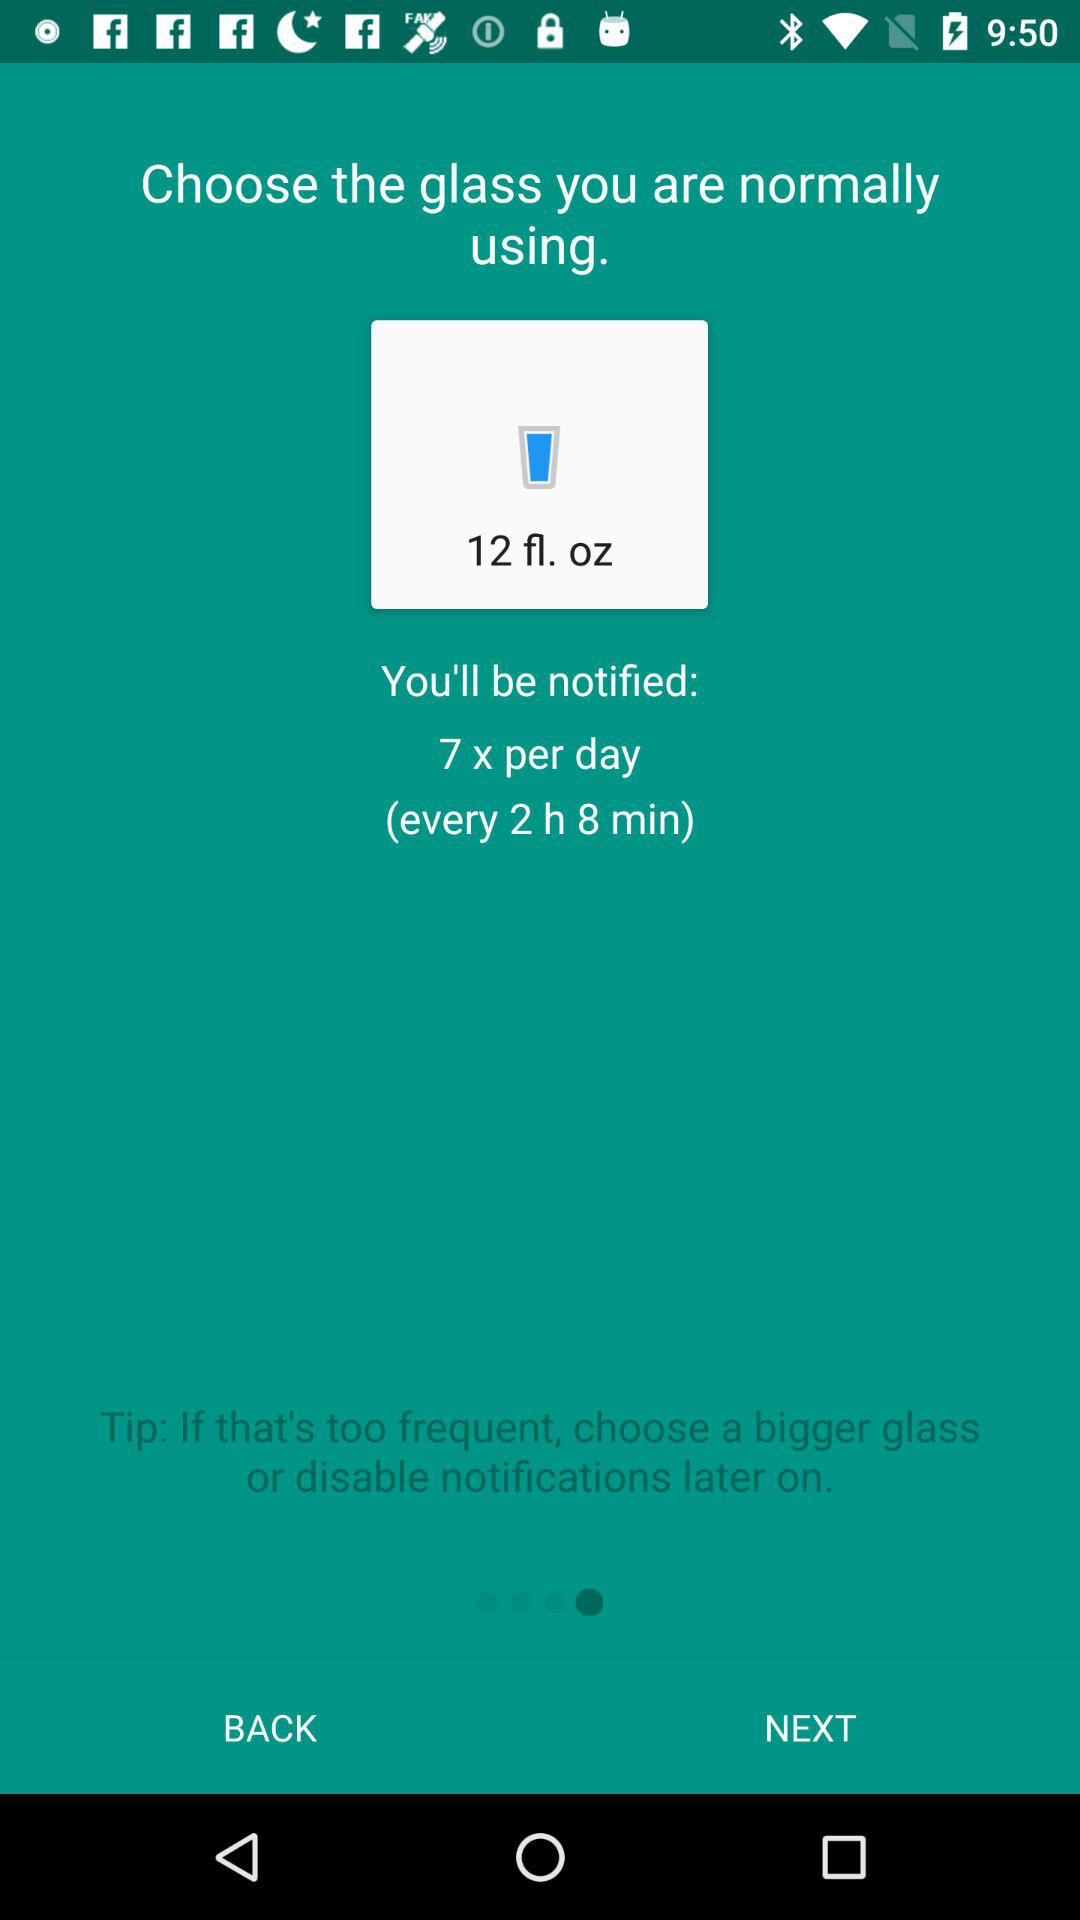What is the tip? The tip is "If that's too frequent, choose a bigger glass or disable notifications later on.". 